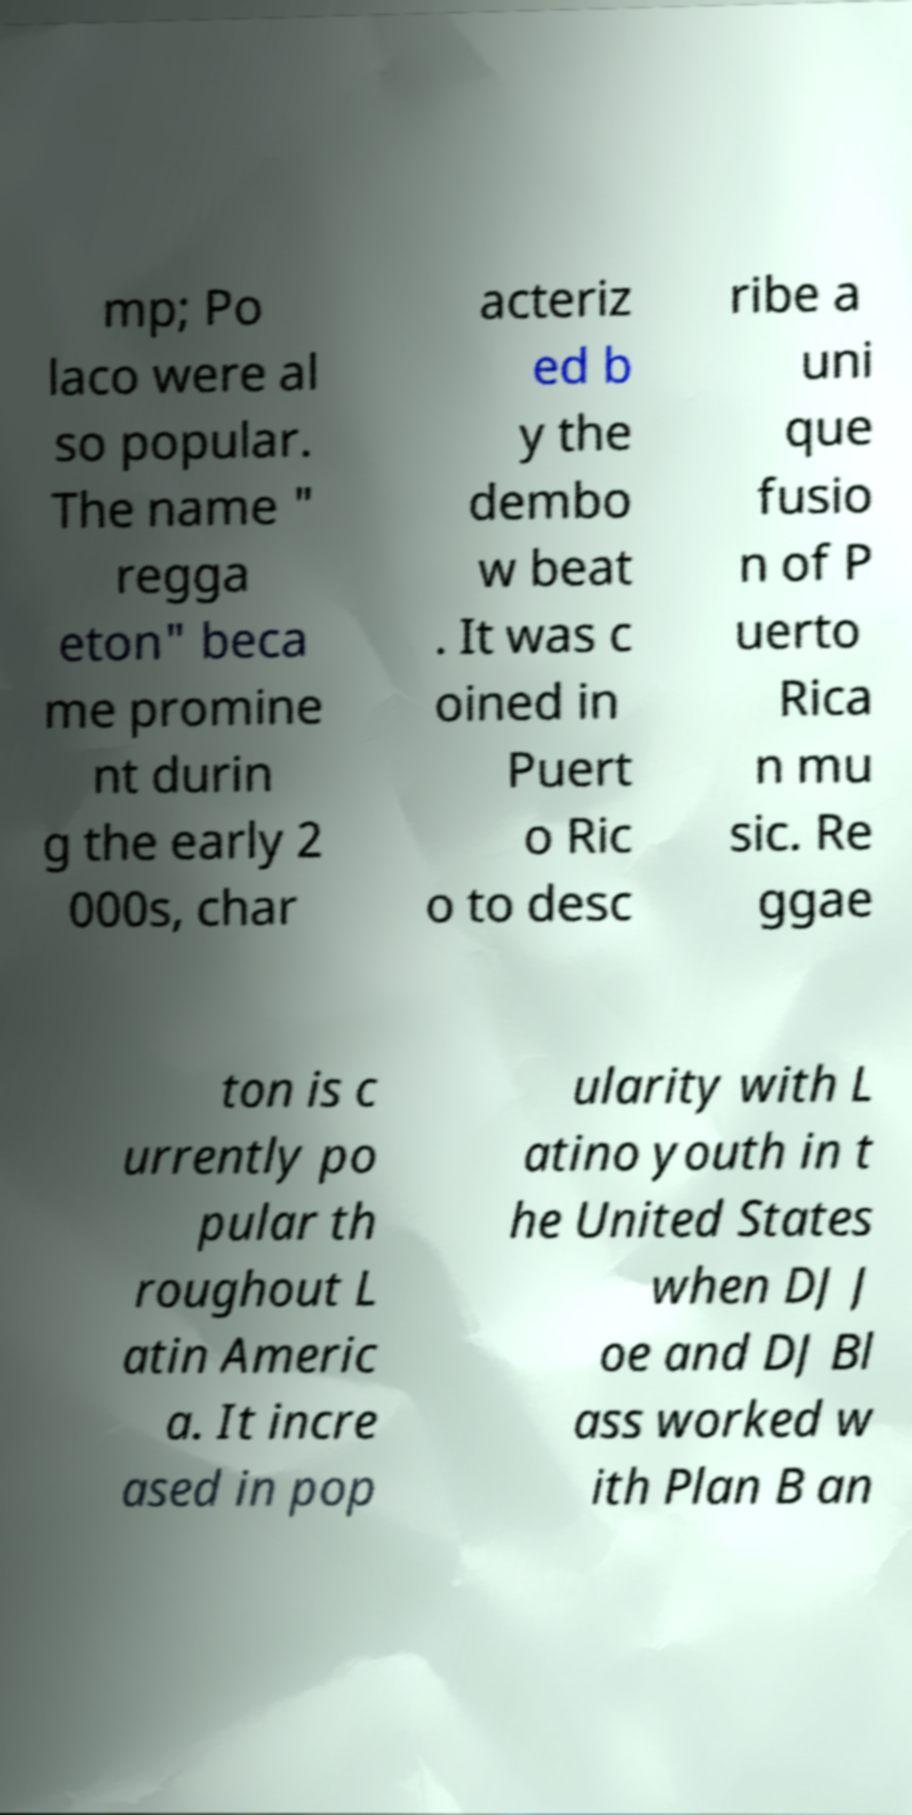Please read and relay the text visible in this image. What does it say? mp; Po laco were al so popular. The name " regga eton" beca me promine nt durin g the early 2 000s, char acteriz ed b y the dembo w beat . It was c oined in Puert o Ric o to desc ribe a uni que fusio n of P uerto Rica n mu sic. Re ggae ton is c urrently po pular th roughout L atin Americ a. It incre ased in pop ularity with L atino youth in t he United States when DJ J oe and DJ Bl ass worked w ith Plan B an 